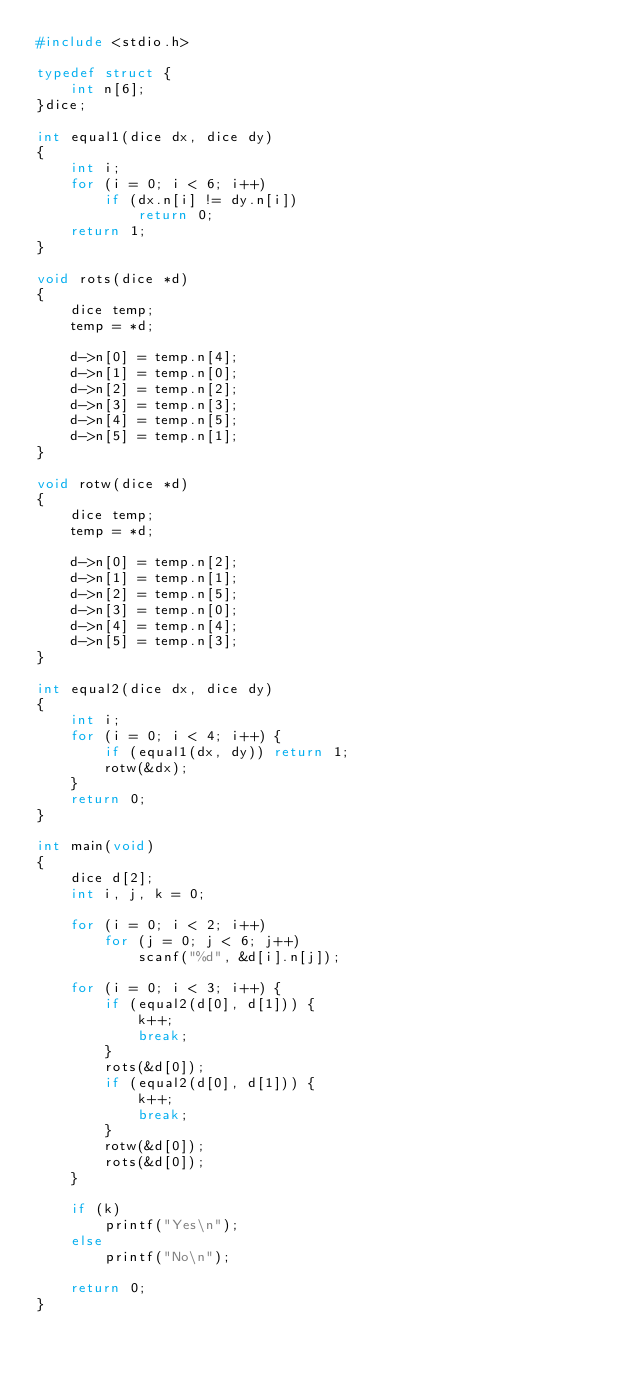<code> <loc_0><loc_0><loc_500><loc_500><_C_>#include <stdio.h>

typedef struct {
	int n[6];
}dice;

int equal1(dice dx, dice dy)
{
	int i;
	for (i = 0; i < 6; i++)
		if (dx.n[i] != dy.n[i])
			return 0;
	return 1;
}

void rots(dice *d)
{
	dice temp;
	temp = *d;

	d->n[0] = temp.n[4];
	d->n[1] = temp.n[0];
	d->n[2] = temp.n[2];
	d->n[3] = temp.n[3];
	d->n[4] = temp.n[5];
	d->n[5] = temp.n[1];
}

void rotw(dice *d)
{
	dice temp;
	temp = *d;

	d->n[0] = temp.n[2];
	d->n[1] = temp.n[1];
	d->n[2] = temp.n[5];
	d->n[3] = temp.n[0];
	d->n[4] = temp.n[4];
	d->n[5] = temp.n[3];
}

int equal2(dice dx, dice dy)
{
	int i;
	for (i = 0; i < 4; i++) {
		if (equal1(dx, dy)) return 1;
		rotw(&dx);
	}
	return 0;
}

int main(void)
{
	dice d[2];
	int i, j, k = 0;

	for (i = 0; i < 2; i++)
		for (j = 0; j < 6; j++)
			scanf("%d", &d[i].n[j]);

	for (i = 0; i < 3; i++) {
		if (equal2(d[0], d[1])) {
			k++;
			break;
		}
		rots(&d[0]);
		if (equal2(d[0], d[1])) {
			k++;
			break;
		}
		rotw(&d[0]);
		rots(&d[0]);
	}

	if (k)
		printf("Yes\n");
	else
		printf("No\n");

	return 0;
}</code> 